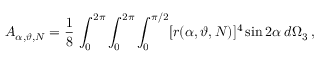Convert formula to latex. <formula><loc_0><loc_0><loc_500><loc_500>A _ { \alpha , \vartheta , N } = \frac { 1 } { 8 } \, \int _ { 0 } ^ { 2 \pi } \int _ { 0 } ^ { 2 \pi } \int _ { 0 } ^ { \pi / 2 } [ r ( \alpha , \vartheta , N ) ] ^ { 4 } \sin 2 \alpha \, d \Omega _ { 3 } \, ,</formula> 